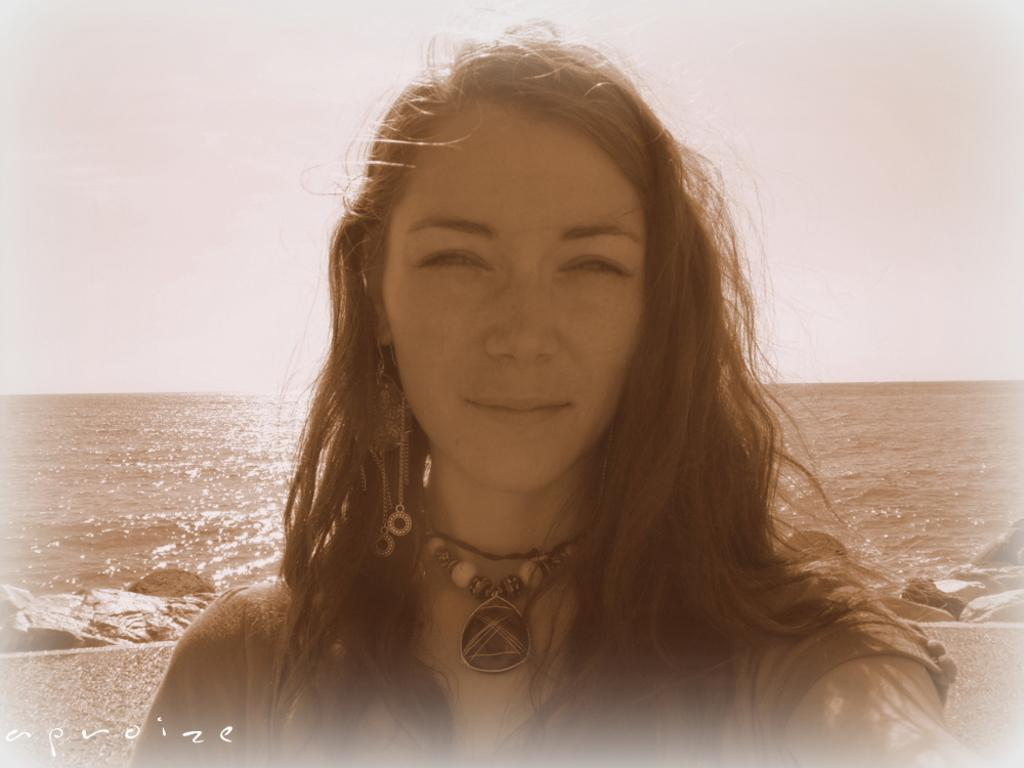Who or what is present in the image? There is a person in the image. What is the person wearing in the image? The person is wearing chains. What can be seen in the background of the image? There are stones and water visible in the background of the image. What is the color of the sky in the image? The sky appears to be white in color. Where is the ladybug market located in the image? There is no ladybug market present in the image. What type of mist can be seen surrounding the person in the image? There is no mist visible in the image; the sky appears to be white in color. 